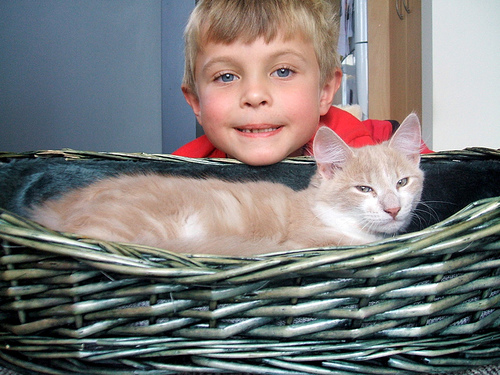<image>
Is there a cat next to the kid? No. The cat is not positioned next to the kid. They are located in different areas of the scene. 